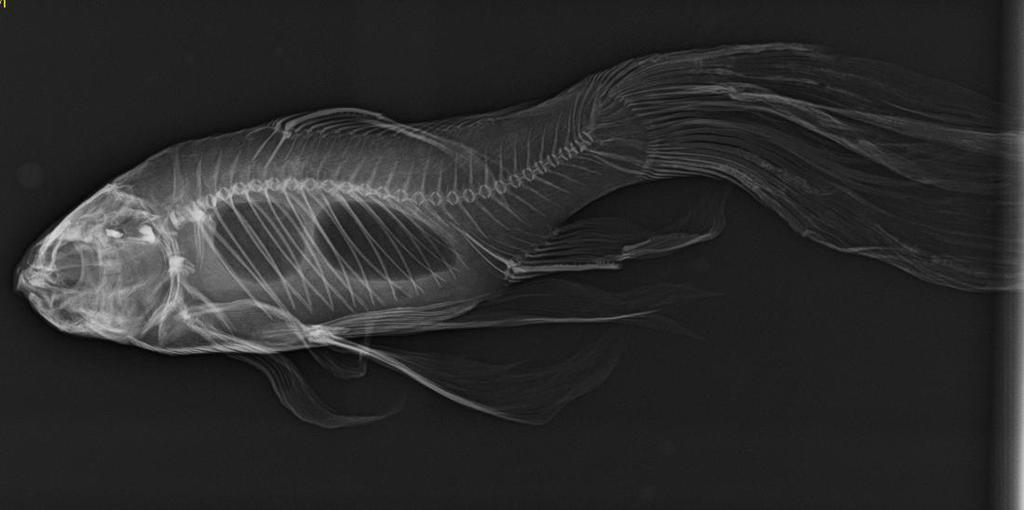Describe this image in one or two sentences. There is a fish skeleton in the foreground of the image and the background is black. 